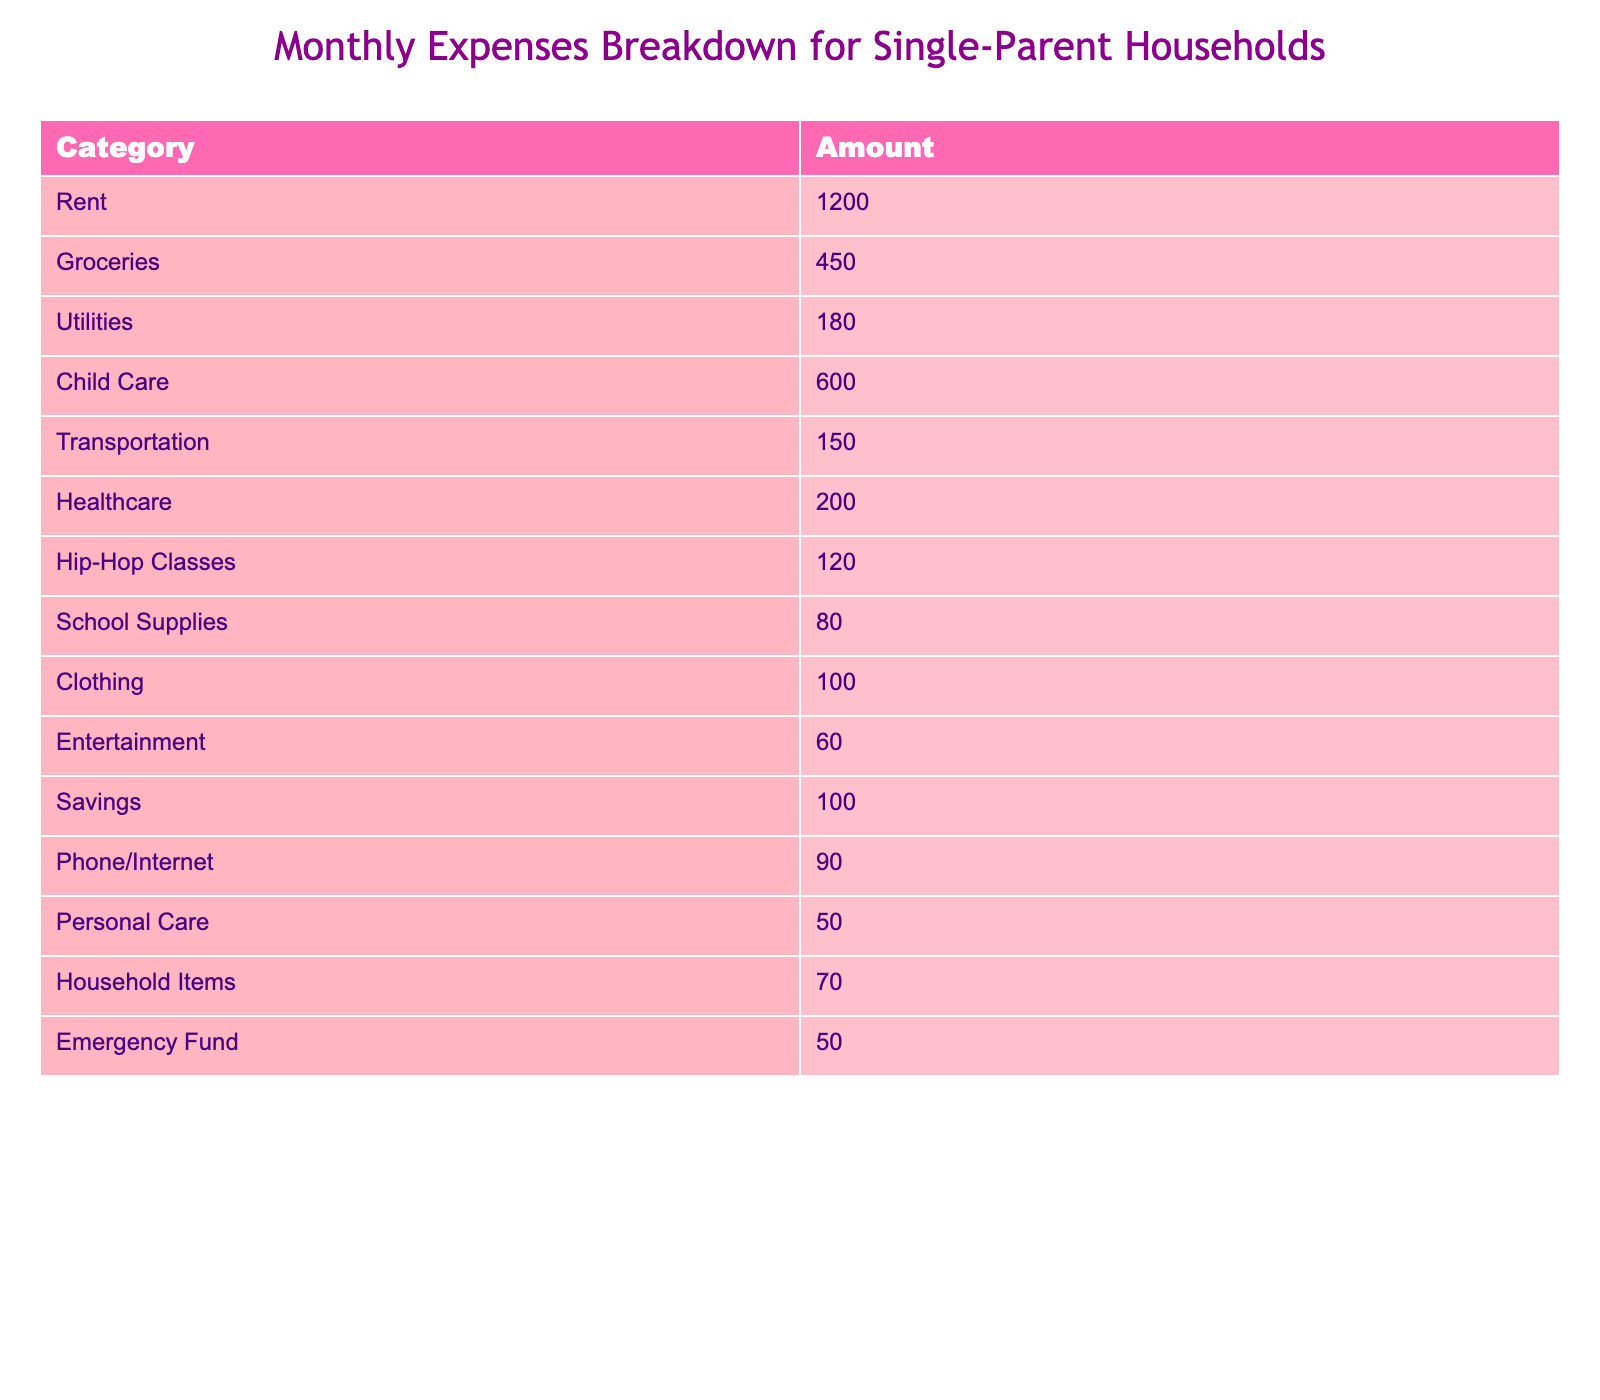What is the total monthly expense for child care? The table shows that the amount allocated for child care is 600. Therefore, the total monthly expense is simply 600.
Answer: 600 How much is spent on groceries compared to transportation? The table lists groceries at 450 and transportation at 150. To compare, we see that groceries cost 450 and transportation costs 150.
Answer: Groceries are 300 more than transportation What is the percentage of total expenses spent on hip-hop classes? First, we total all expenses: 1200 + 450 + 180 + 600 + 150 + 200 + 120 + 80 + 100 + 60 + 100 + 90 + 50 + 70 + 50 =  3070. Hip-hop classes cost 120. To find the percentage, we calculate (120 / 3070) * 100, which is approximately 3.91%.
Answer: Approximately 3.91% Is the amount spent on entertainment higher than that of clothing? The table shows entertainment costs 60 and clothing costs 100. Since 60 is less than 100, we determine that the entertainment expense is not higher than clothing.
Answer: No What are the total expenses for the “needs” category (rent, groceries, utilities, child care, transportation, and healthcare)? Needs include rent (1200), groceries (450), utilities (180), child care (600), transportation (150), and healthcare (200). Adding these gives: 1200 + 450 + 180 + 600 + 150 + 200 = 2880.
Answer: 2880 What is the difference between the total expenses for personal care and emergency fund? Personal care is 50 and the emergency fund is also 50. The difference is 50 - 50 = 0, showing no difference in these two categories.
Answer: 0 